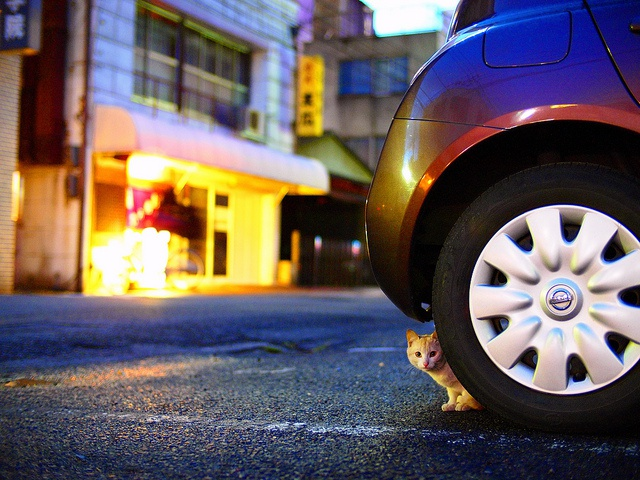Describe the objects in this image and their specific colors. I can see car in black, lightgray, darkblue, and navy tones and cat in black, brown, tan, and maroon tones in this image. 